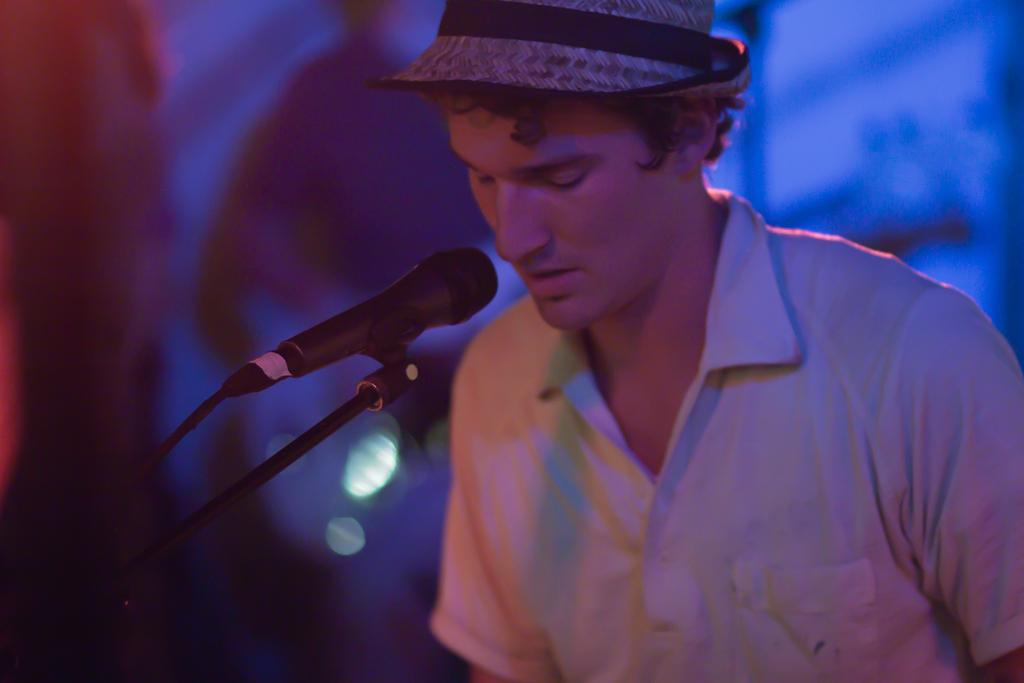What is the person in the image doing? The person is standing in the image and singing in front of a microphone. What is the person wearing? The person is wearing a white shirt and black pants. What color is the background of the image? The background of the image is blue. What type of stem can be seen growing from the person's head in the image? There is no stem growing from the person's head in the image. Is the person performing on a stage in the image? The provided facts do not mention a stage, so it cannot be confirmed from the image. 